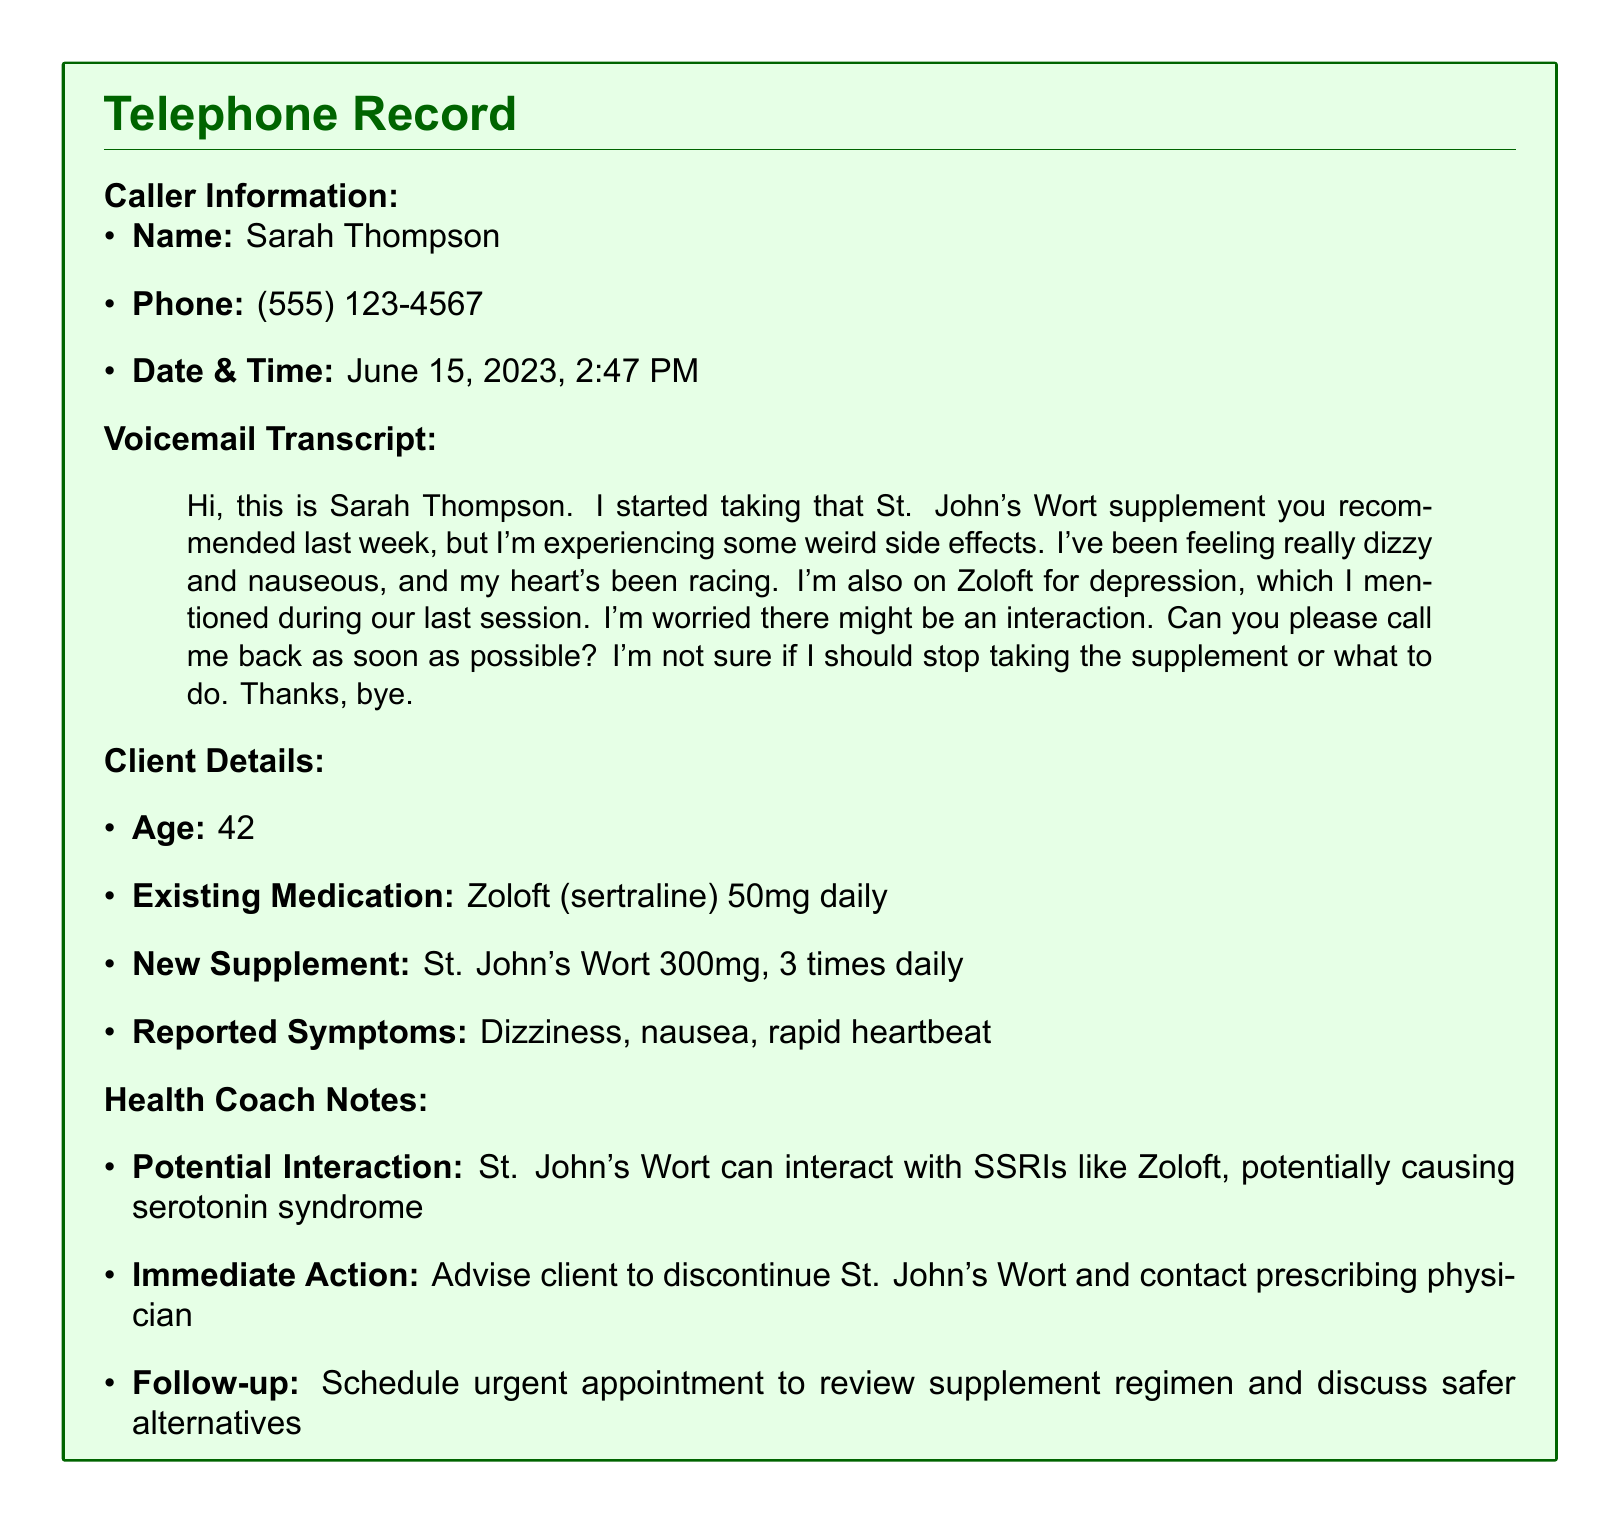What is the caller's name? The caller's name, as stated in the document, is the individual who left the voicemail.
Answer: Sarah Thompson What medication is the client currently taking? The existing medication is listed under Client Details in the document.
Answer: Zoloft What symptoms did the client report? The document outlines the reported symptoms in the Client Details section.
Answer: Dizziness, nausea, rapid heartbeat When did the client leave the voicemail? The date and time of the voicemail are explicitly mentioned in the Caller Information section.
Answer: June 15, 2023, 2:47 PM What supplement did the client start taking? The new supplement is detailed in the Client Details section of the document.
Answer: St. John's Wort What dosage of St. John's Wort is the client taking? The document specifies the dosage and frequency of the new supplement in the Client Details.
Answer: 300mg, 3 times daily What potential interaction is noted in the health coach's notes? The potential interaction is mentioned in the Health Coach Notes.
Answer: Interaction with SSRIs, serotonin syndrome What action should the client take regarding the supplement? The recommended action is provided in the Health Coach Notes section of the document.
Answer: Discontinue St. John's Wort What is the age of the client? The client's age is stated in the Client Details section.
Answer: 42 